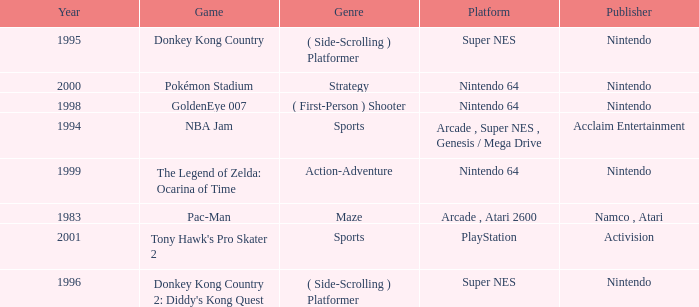Which Genre has a Year larger than 1999, and a Game of tony hawk's pro skater 2? Sports. 